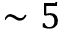Convert formula to latex. <formula><loc_0><loc_0><loc_500><loc_500>\sim 5</formula> 